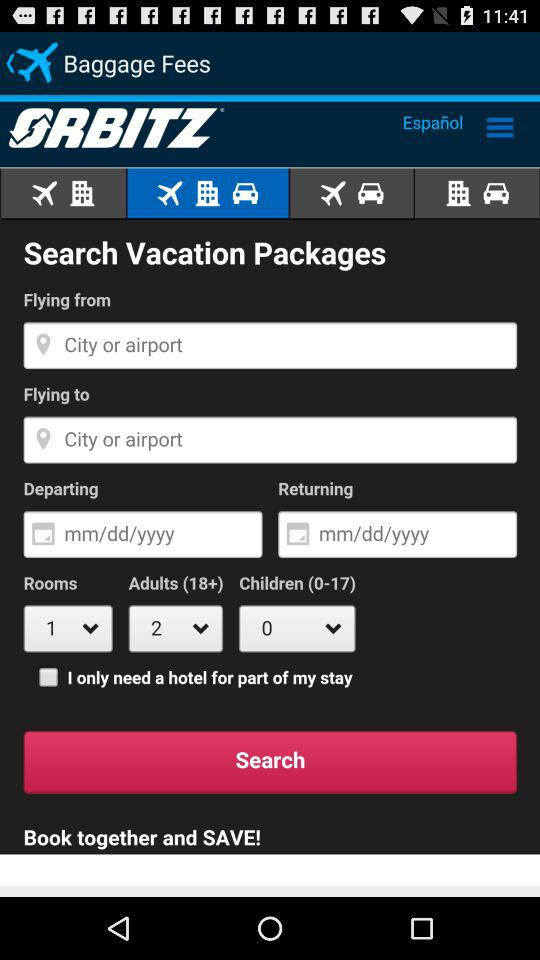How many adults are selected? There are 2 adults selected. 